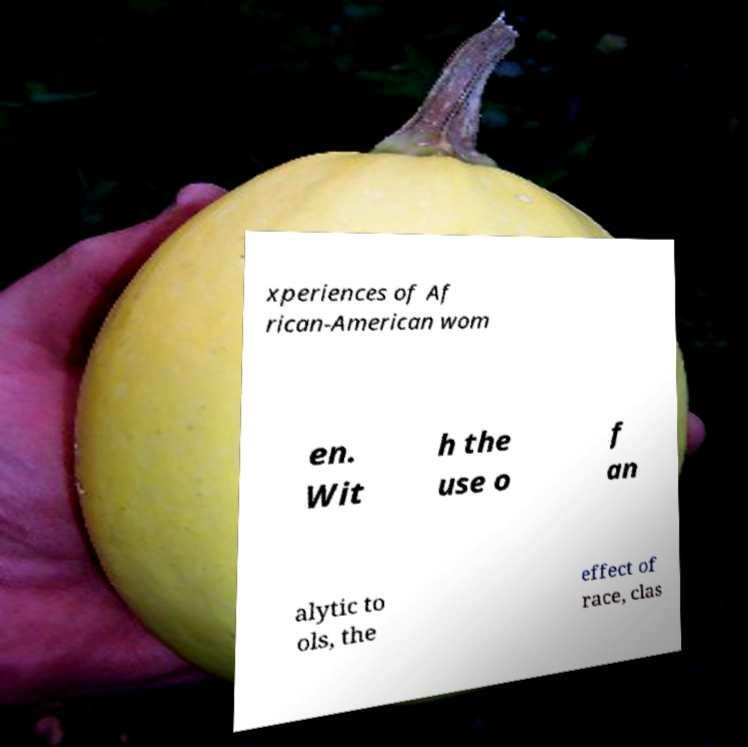What messages or text are displayed in this image? I need them in a readable, typed format. xperiences of Af rican-American wom en. Wit h the use o f an alytic to ols, the effect of race, clas 